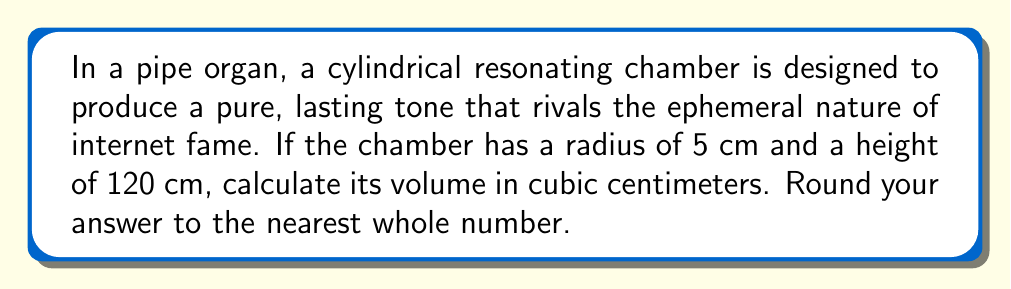Can you answer this question? To calculate the volume of a cylindrical resonating chamber, we use the formula for the volume of a cylinder:

$$V = \pi r^2 h$$

Where:
$V$ = volume
$r$ = radius of the base
$h$ = height of the cylinder

Given:
$r = 5$ cm
$h = 120$ cm

Step 1: Substitute the values into the formula
$$V = \pi (5\text{ cm})^2 (120\text{ cm})$$

Step 2: Calculate the square of the radius
$$V = \pi (25\text{ cm}^2) (120\text{ cm})$$

Step 3: Multiply the values
$$V = 3000\pi\text{ cm}^3$$

Step 4: Calculate the final value (using $\pi \approx 3.14159$)
$$V \approx 3000 \times 3.14159 \text{ cm}^3 = 9424.77\text{ cm}^3$$

Step 5: Round to the nearest whole number
$$V \approx 9425\text{ cm}^3$$
Answer: 9425 cm³ 